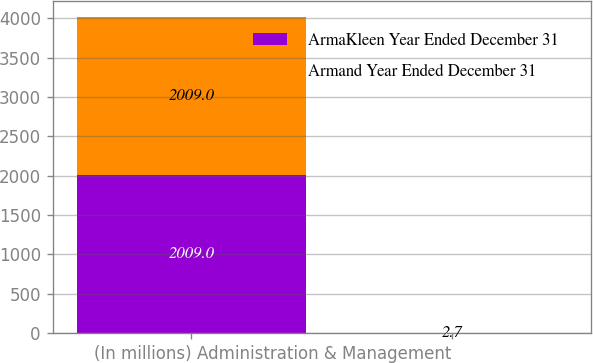Convert chart to OTSL. <chart><loc_0><loc_0><loc_500><loc_500><stacked_bar_chart><ecel><fcel>(In millions)<fcel>Administration & Management<nl><fcel>ArmaKleen Year Ended December 31<fcel>2009<fcel>1.7<nl><fcel>Armand Year Ended December 31<fcel>2009<fcel>2.7<nl></chart> 